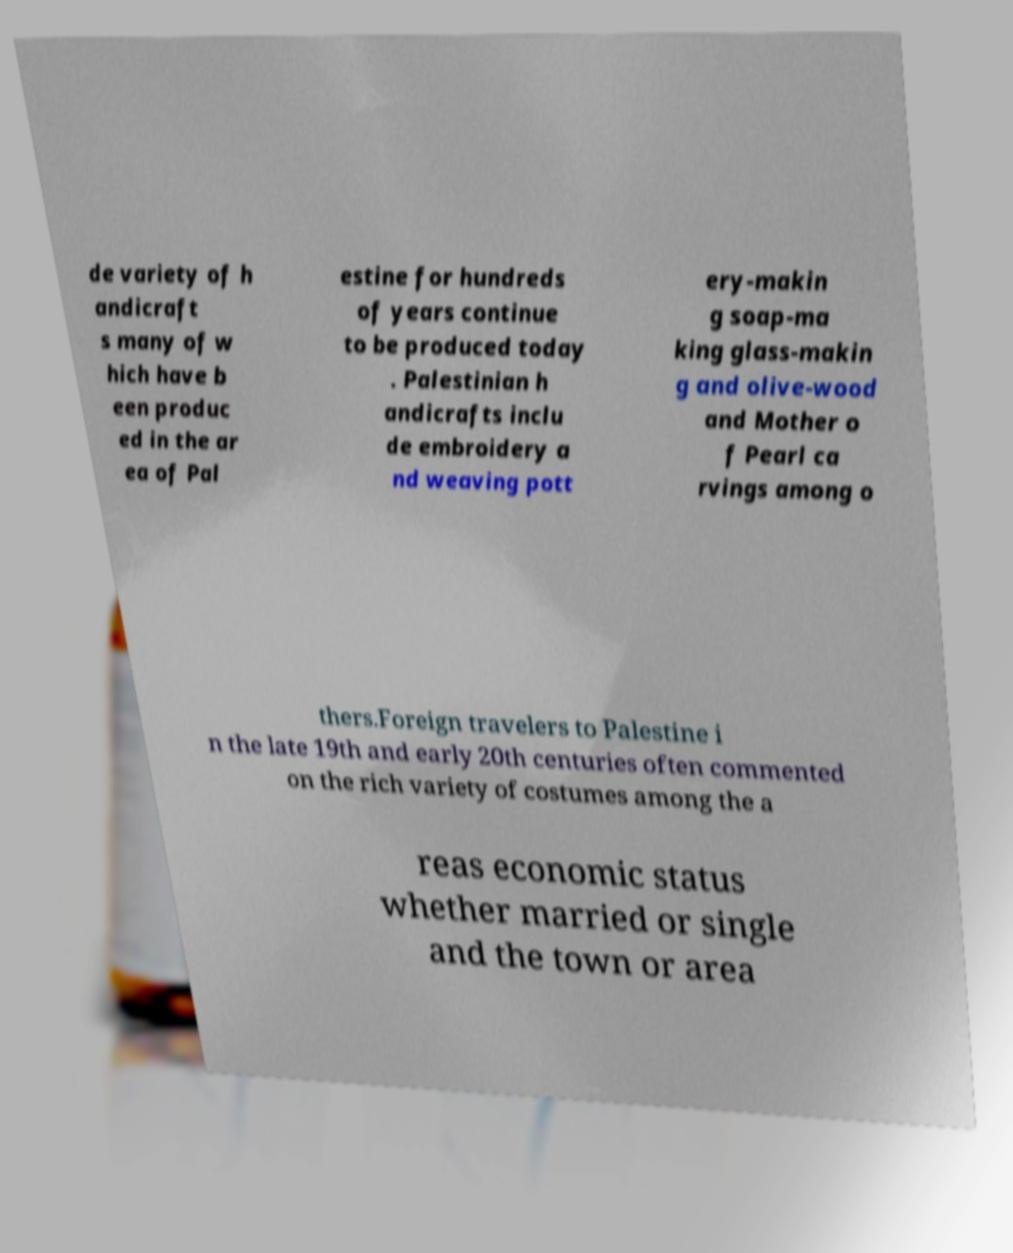Please identify and transcribe the text found in this image. de variety of h andicraft s many of w hich have b een produc ed in the ar ea of Pal estine for hundreds of years continue to be produced today . Palestinian h andicrafts inclu de embroidery a nd weaving pott ery-makin g soap-ma king glass-makin g and olive-wood and Mother o f Pearl ca rvings among o thers.Foreign travelers to Palestine i n the late 19th and early 20th centuries often commented on the rich variety of costumes among the a reas economic status whether married or single and the town or area 